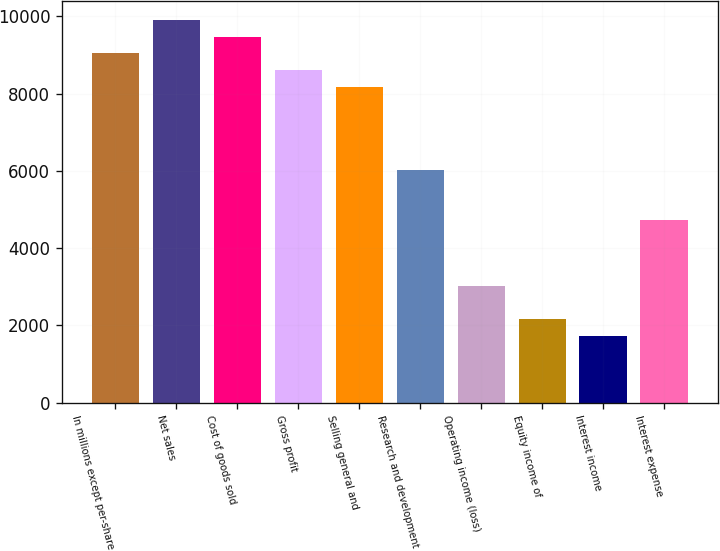<chart> <loc_0><loc_0><loc_500><loc_500><bar_chart><fcel>In millions except per-share<fcel>Net sales<fcel>Cost of goods sold<fcel>Gross profit<fcel>Selling general and<fcel>Research and development<fcel>Operating income (loss)<fcel>Equity income of<fcel>Interest income<fcel>Interest expense<nl><fcel>9044.06<fcel>9905.38<fcel>9474.72<fcel>8613.4<fcel>8182.74<fcel>6029.44<fcel>3014.82<fcel>2153.5<fcel>1722.84<fcel>4737.46<nl></chart> 